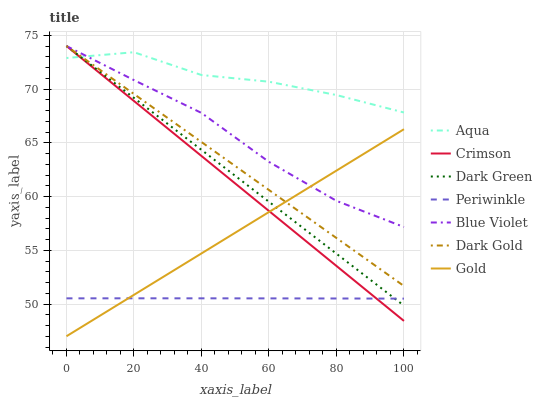Does Periwinkle have the minimum area under the curve?
Answer yes or no. Yes. Does Aqua have the maximum area under the curve?
Answer yes or no. Yes. Does Dark Gold have the minimum area under the curve?
Answer yes or no. No. Does Dark Gold have the maximum area under the curve?
Answer yes or no. No. Is Gold the smoothest?
Answer yes or no. Yes. Is Aqua the roughest?
Answer yes or no. Yes. Is Dark Gold the smoothest?
Answer yes or no. No. Is Dark Gold the roughest?
Answer yes or no. No. Does Gold have the lowest value?
Answer yes or no. Yes. Does Dark Gold have the lowest value?
Answer yes or no. No. Does Dark Green have the highest value?
Answer yes or no. Yes. Does Aqua have the highest value?
Answer yes or no. No. Is Periwinkle less than Dark Gold?
Answer yes or no. Yes. Is Blue Violet greater than Periwinkle?
Answer yes or no. Yes. Does Gold intersect Crimson?
Answer yes or no. Yes. Is Gold less than Crimson?
Answer yes or no. No. Is Gold greater than Crimson?
Answer yes or no. No. Does Periwinkle intersect Dark Gold?
Answer yes or no. No. 